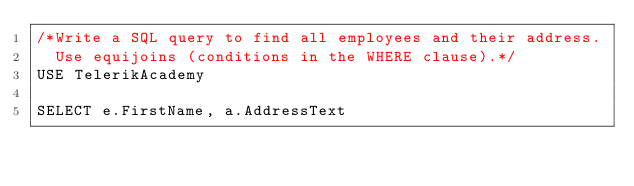Convert code to text. <code><loc_0><loc_0><loc_500><loc_500><_SQL_>/*Write a SQL query to find all employees and their address. 
  Use equijoins (conditions in the WHERE clause).*/
USE TelerikAcademy

SELECT e.FirstName, a.AddressText</code> 